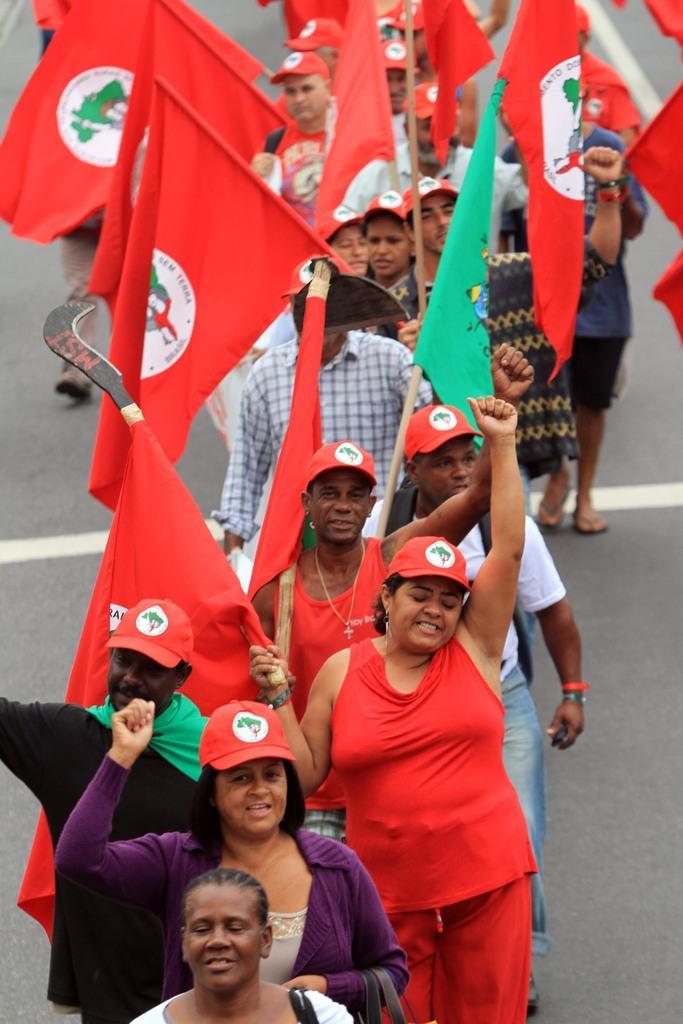Could you give a brief overview of what you see in this image? In this image I can see number of people are standing and I can see most of them are wearing red color caps. I can also see most of them are holding flags and on these flags I can see few logos are printed. 